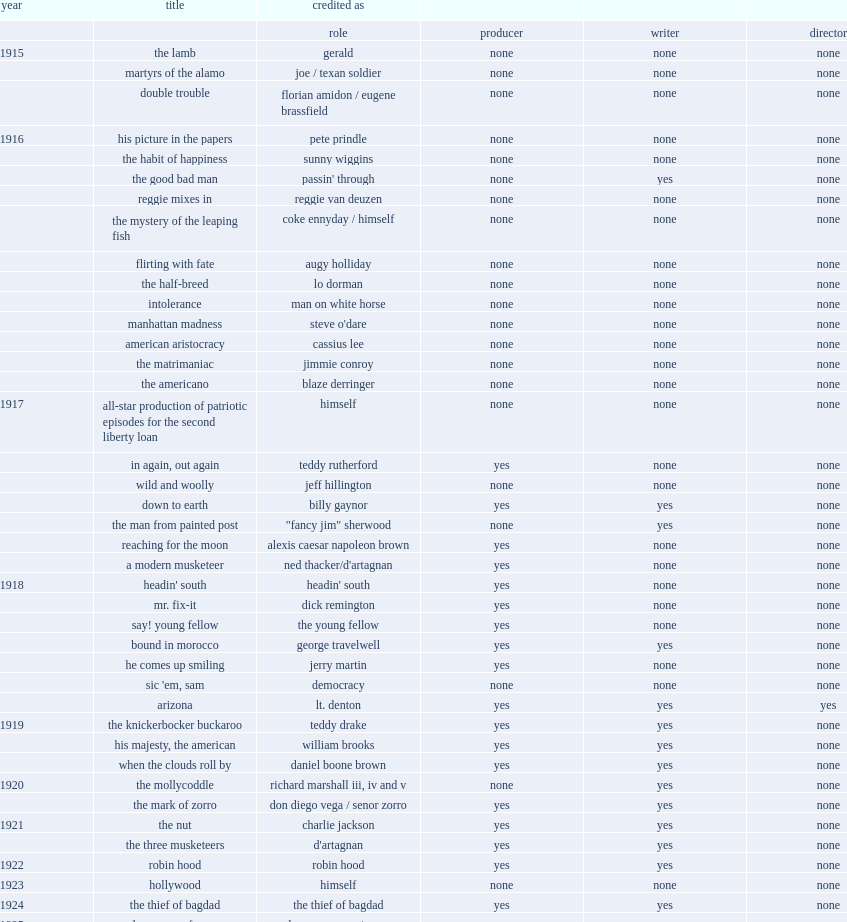Which club did douglas fairbanks play for in 1929? The taming of the shrew. 